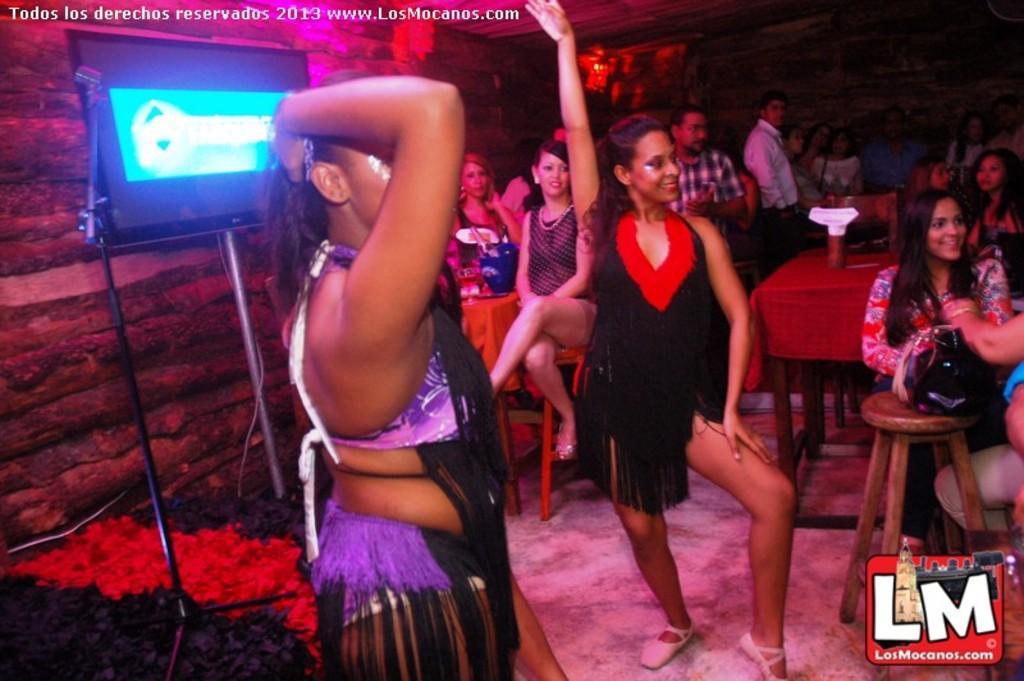In one or two sentences, can you explain what this image depicts? In the image there are two ladies dancing. Behind them there are few people sitting. There are chairs and tables in the background. Also there is a screen and rods. Behind the screen there are wooden rods. In the bottom right of the image there is a logo. 